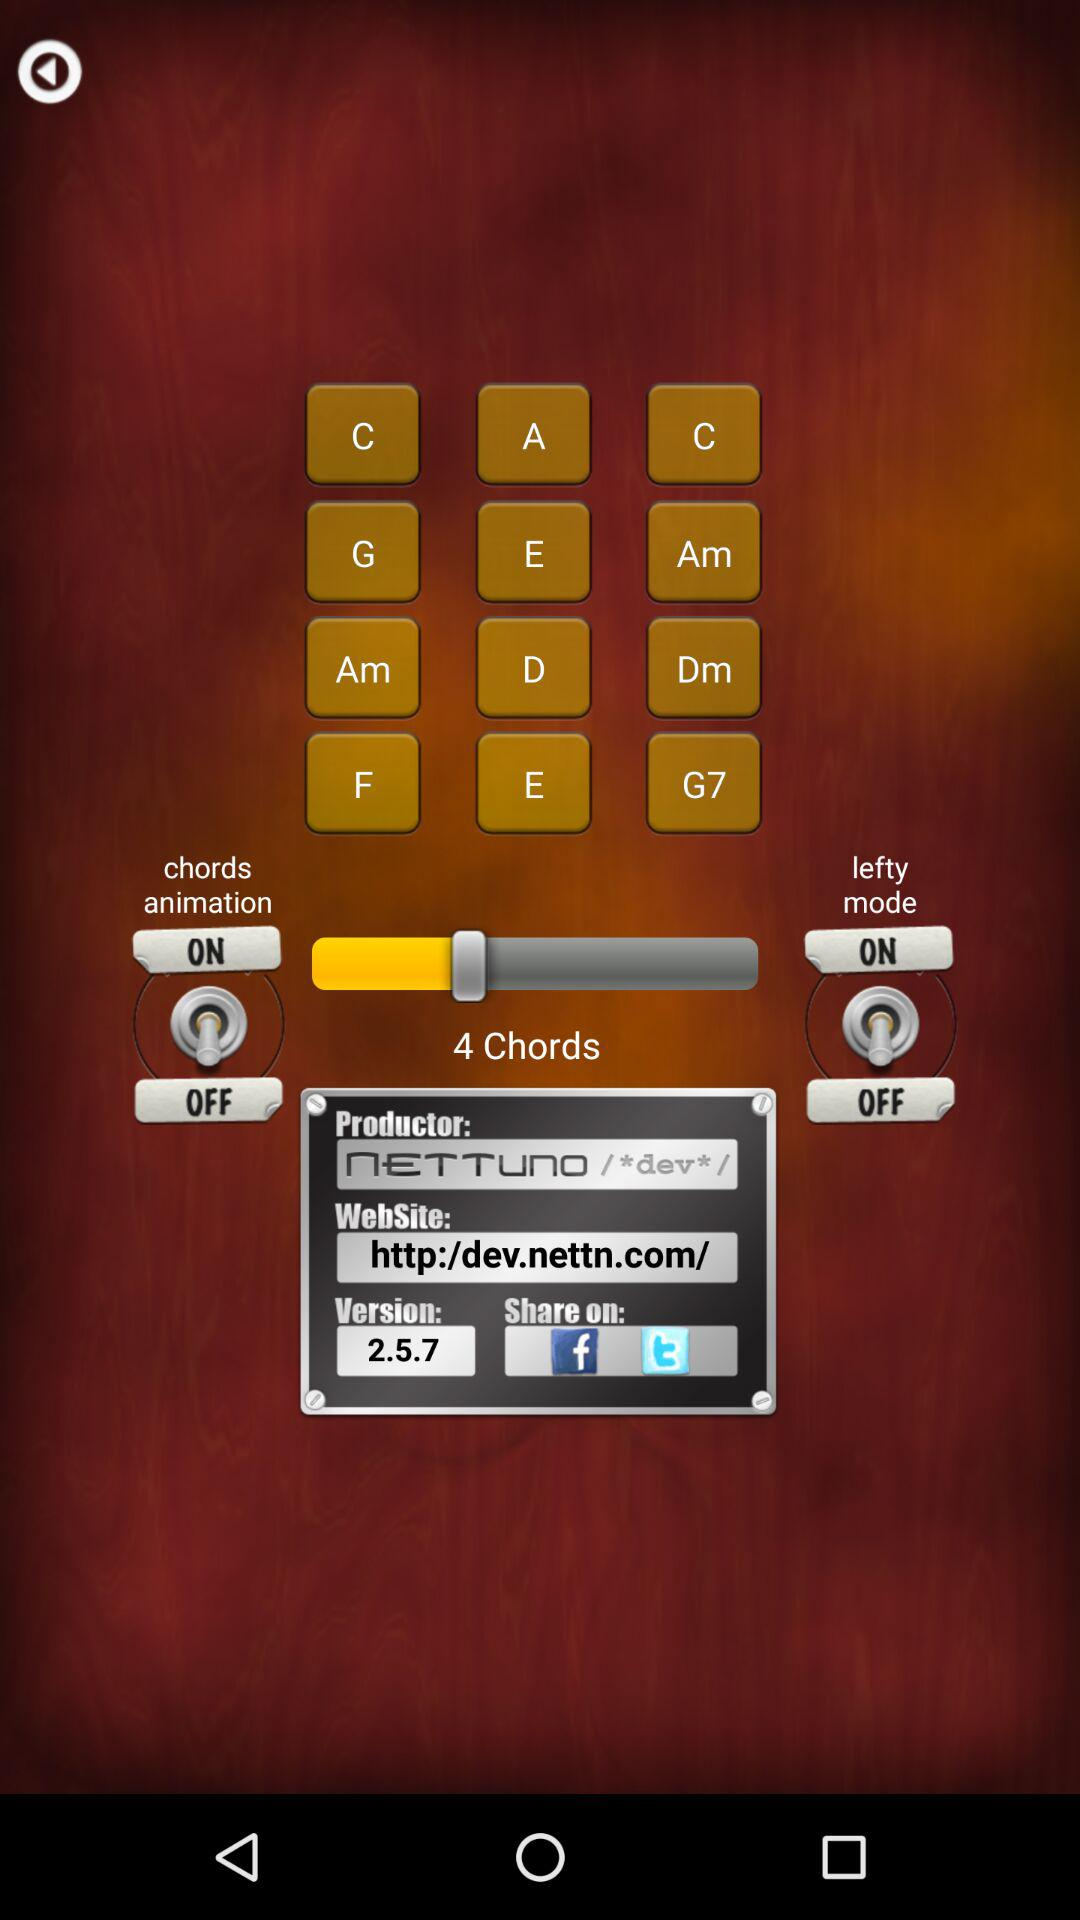What version is used? The version is 2.5.7. 